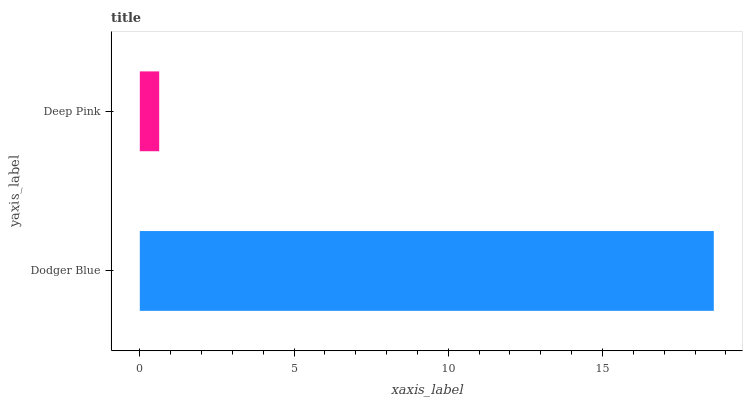Is Deep Pink the minimum?
Answer yes or no. Yes. Is Dodger Blue the maximum?
Answer yes or no. Yes. Is Deep Pink the maximum?
Answer yes or no. No. Is Dodger Blue greater than Deep Pink?
Answer yes or no. Yes. Is Deep Pink less than Dodger Blue?
Answer yes or no. Yes. Is Deep Pink greater than Dodger Blue?
Answer yes or no. No. Is Dodger Blue less than Deep Pink?
Answer yes or no. No. Is Dodger Blue the high median?
Answer yes or no. Yes. Is Deep Pink the low median?
Answer yes or no. Yes. Is Deep Pink the high median?
Answer yes or no. No. Is Dodger Blue the low median?
Answer yes or no. No. 